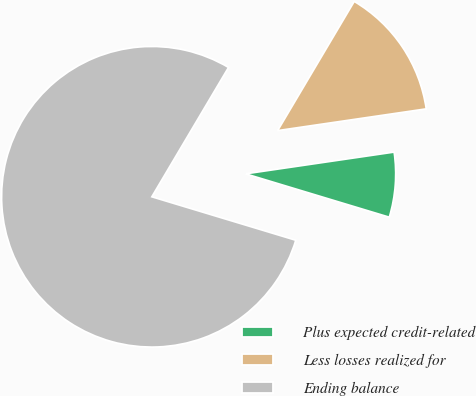<chart> <loc_0><loc_0><loc_500><loc_500><pie_chart><fcel>Plus expected credit-related<fcel>Less losses realized for<fcel>Ending balance<nl><fcel>6.98%<fcel>14.17%<fcel>78.86%<nl></chart> 